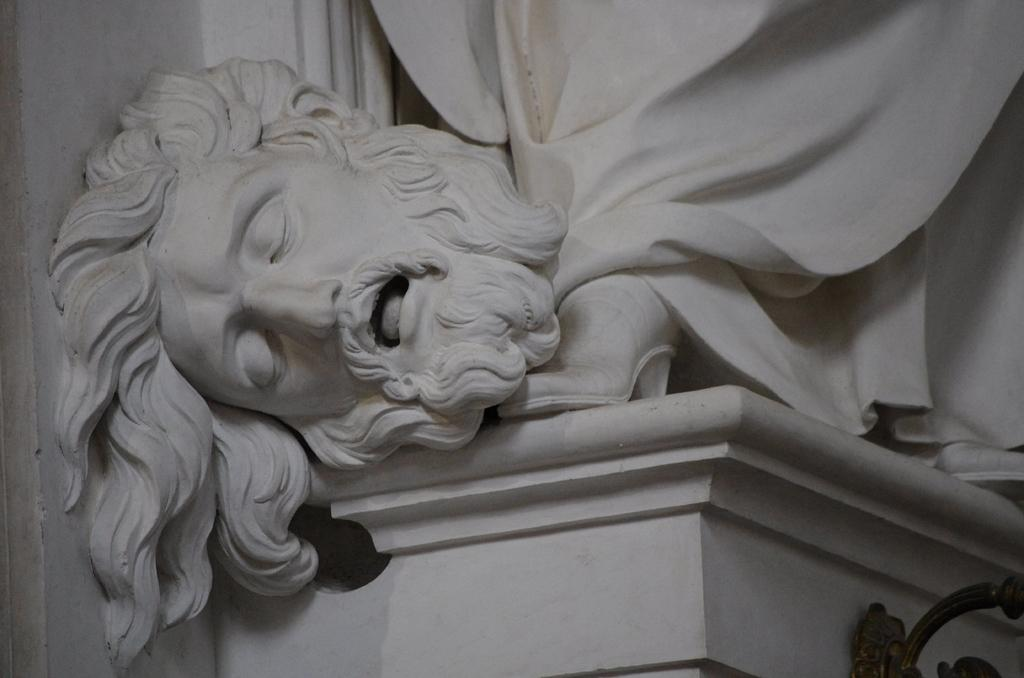What is the main subject of the image? The main subject of the image is a statue of a person's head. How is the statue positioned in the image? The statue is on a pedestal. What material is the object at the bottom of the image made of? The object at the bottom of the image is made of iron. What type of suit is the person wearing on stage in the image? There is no person wearing a suit on stage in the image; it features a statue of a person's head on a pedestal. How many beads are visible on the statue in the image? There are no beads visible on the statue in the image; it is a statue of a person's head made of a different material. 